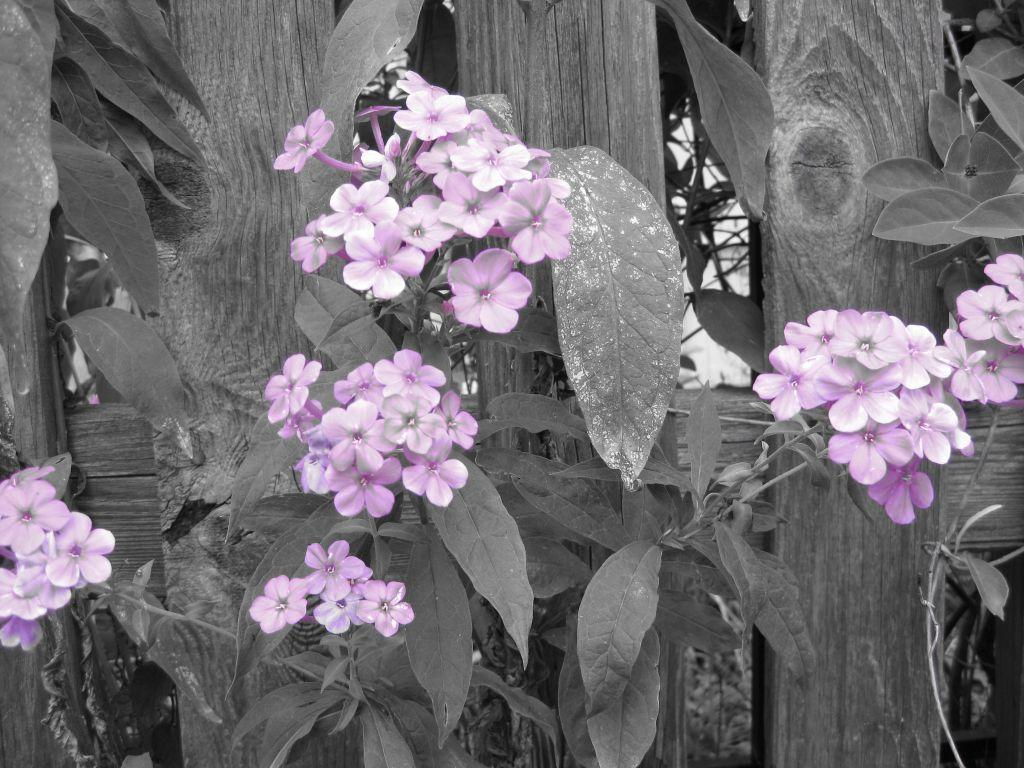What type of flowers can be seen in the image? There are purple flowers in the image. What kind of structure is visible in the background of the image? There is a wooden fence in the background of the image. What other natural elements are present in the image? There are leaves in the image. What type of plate is being used to hold the brain in the image? There is no plate or brain present in the image; it features purple flowers and a wooden fence. 